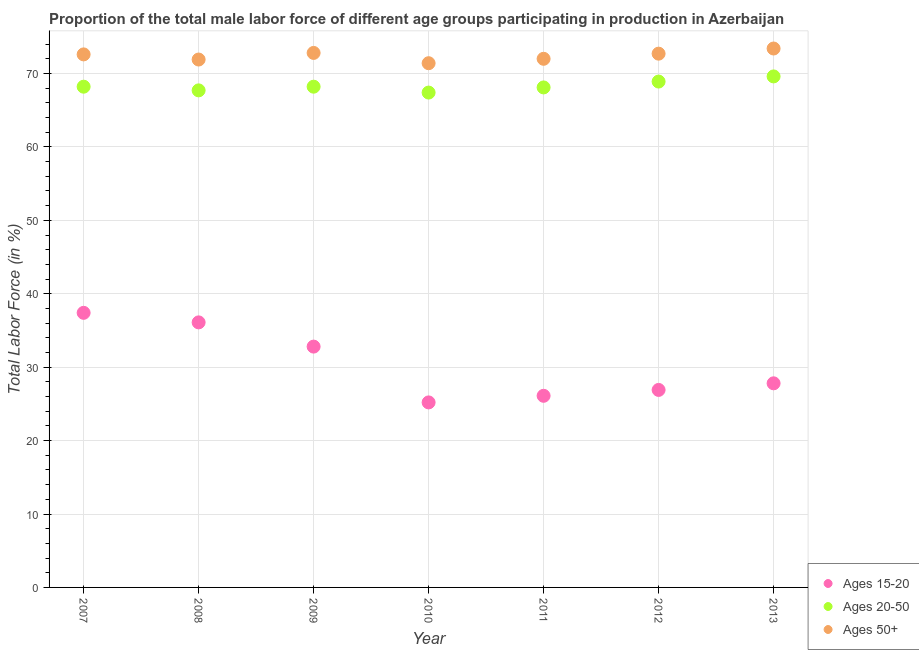How many different coloured dotlines are there?
Keep it short and to the point. 3. What is the percentage of male labor force within the age group 15-20 in 2007?
Keep it short and to the point. 37.4. Across all years, what is the maximum percentage of male labor force within the age group 15-20?
Make the answer very short. 37.4. Across all years, what is the minimum percentage of male labor force above age 50?
Your answer should be compact. 71.4. In which year was the percentage of male labor force above age 50 maximum?
Ensure brevity in your answer.  2013. In which year was the percentage of male labor force above age 50 minimum?
Your answer should be very brief. 2010. What is the total percentage of male labor force above age 50 in the graph?
Make the answer very short. 506.8. What is the difference between the percentage of male labor force within the age group 15-20 in 2009 and that in 2013?
Ensure brevity in your answer.  5. What is the difference between the percentage of male labor force within the age group 20-50 in 2011 and the percentage of male labor force within the age group 15-20 in 2012?
Provide a succinct answer. 41.2. What is the average percentage of male labor force within the age group 20-50 per year?
Give a very brief answer. 68.3. In the year 2008, what is the difference between the percentage of male labor force above age 50 and percentage of male labor force within the age group 20-50?
Offer a very short reply. 4.2. What is the ratio of the percentage of male labor force above age 50 in 2009 to that in 2013?
Offer a terse response. 0.99. Is the percentage of male labor force within the age group 20-50 in 2010 less than that in 2011?
Make the answer very short. Yes. Is the difference between the percentage of male labor force within the age group 20-50 in 2008 and 2012 greater than the difference between the percentage of male labor force above age 50 in 2008 and 2012?
Make the answer very short. No. What is the difference between the highest and the second highest percentage of male labor force within the age group 15-20?
Keep it short and to the point. 1.3. What is the difference between the highest and the lowest percentage of male labor force within the age group 20-50?
Keep it short and to the point. 2.2. Is the sum of the percentage of male labor force within the age group 15-20 in 2009 and 2010 greater than the maximum percentage of male labor force above age 50 across all years?
Offer a terse response. No. Is it the case that in every year, the sum of the percentage of male labor force within the age group 15-20 and percentage of male labor force within the age group 20-50 is greater than the percentage of male labor force above age 50?
Provide a succinct answer. Yes. Does the percentage of male labor force within the age group 15-20 monotonically increase over the years?
Give a very brief answer. No. Is the percentage of male labor force within the age group 15-20 strictly less than the percentage of male labor force above age 50 over the years?
Give a very brief answer. Yes. How many dotlines are there?
Make the answer very short. 3. How many years are there in the graph?
Keep it short and to the point. 7. Where does the legend appear in the graph?
Ensure brevity in your answer.  Bottom right. How are the legend labels stacked?
Ensure brevity in your answer.  Vertical. What is the title of the graph?
Your answer should be compact. Proportion of the total male labor force of different age groups participating in production in Azerbaijan. What is the label or title of the Y-axis?
Provide a succinct answer. Total Labor Force (in %). What is the Total Labor Force (in %) in Ages 15-20 in 2007?
Give a very brief answer. 37.4. What is the Total Labor Force (in %) of Ages 20-50 in 2007?
Offer a terse response. 68.2. What is the Total Labor Force (in %) in Ages 50+ in 2007?
Your answer should be very brief. 72.6. What is the Total Labor Force (in %) in Ages 15-20 in 2008?
Provide a short and direct response. 36.1. What is the Total Labor Force (in %) in Ages 20-50 in 2008?
Offer a terse response. 67.7. What is the Total Labor Force (in %) of Ages 50+ in 2008?
Your answer should be compact. 71.9. What is the Total Labor Force (in %) of Ages 15-20 in 2009?
Your response must be concise. 32.8. What is the Total Labor Force (in %) of Ages 20-50 in 2009?
Offer a terse response. 68.2. What is the Total Labor Force (in %) of Ages 50+ in 2009?
Keep it short and to the point. 72.8. What is the Total Labor Force (in %) in Ages 15-20 in 2010?
Offer a terse response. 25.2. What is the Total Labor Force (in %) in Ages 20-50 in 2010?
Your answer should be compact. 67.4. What is the Total Labor Force (in %) of Ages 50+ in 2010?
Make the answer very short. 71.4. What is the Total Labor Force (in %) in Ages 15-20 in 2011?
Give a very brief answer. 26.1. What is the Total Labor Force (in %) of Ages 20-50 in 2011?
Make the answer very short. 68.1. What is the Total Labor Force (in %) in Ages 50+ in 2011?
Your answer should be compact. 72. What is the Total Labor Force (in %) of Ages 15-20 in 2012?
Provide a succinct answer. 26.9. What is the Total Labor Force (in %) in Ages 20-50 in 2012?
Provide a short and direct response. 68.9. What is the Total Labor Force (in %) of Ages 50+ in 2012?
Offer a terse response. 72.7. What is the Total Labor Force (in %) of Ages 15-20 in 2013?
Ensure brevity in your answer.  27.8. What is the Total Labor Force (in %) of Ages 20-50 in 2013?
Offer a very short reply. 69.6. What is the Total Labor Force (in %) in Ages 50+ in 2013?
Give a very brief answer. 73.4. Across all years, what is the maximum Total Labor Force (in %) in Ages 15-20?
Ensure brevity in your answer.  37.4. Across all years, what is the maximum Total Labor Force (in %) in Ages 20-50?
Offer a terse response. 69.6. Across all years, what is the maximum Total Labor Force (in %) of Ages 50+?
Give a very brief answer. 73.4. Across all years, what is the minimum Total Labor Force (in %) in Ages 15-20?
Your answer should be very brief. 25.2. Across all years, what is the minimum Total Labor Force (in %) in Ages 20-50?
Your answer should be compact. 67.4. Across all years, what is the minimum Total Labor Force (in %) in Ages 50+?
Provide a short and direct response. 71.4. What is the total Total Labor Force (in %) of Ages 15-20 in the graph?
Ensure brevity in your answer.  212.3. What is the total Total Labor Force (in %) in Ages 20-50 in the graph?
Offer a terse response. 478.1. What is the total Total Labor Force (in %) of Ages 50+ in the graph?
Make the answer very short. 506.8. What is the difference between the Total Labor Force (in %) of Ages 50+ in 2007 and that in 2008?
Give a very brief answer. 0.7. What is the difference between the Total Labor Force (in %) in Ages 20-50 in 2007 and that in 2009?
Keep it short and to the point. 0. What is the difference between the Total Labor Force (in %) of Ages 15-20 in 2007 and that in 2010?
Make the answer very short. 12.2. What is the difference between the Total Labor Force (in %) of Ages 50+ in 2007 and that in 2011?
Ensure brevity in your answer.  0.6. What is the difference between the Total Labor Force (in %) of Ages 20-50 in 2007 and that in 2012?
Provide a short and direct response. -0.7. What is the difference between the Total Labor Force (in %) of Ages 50+ in 2007 and that in 2012?
Your answer should be compact. -0.1. What is the difference between the Total Labor Force (in %) in Ages 15-20 in 2008 and that in 2009?
Keep it short and to the point. 3.3. What is the difference between the Total Labor Force (in %) of Ages 20-50 in 2008 and that in 2009?
Your answer should be compact. -0.5. What is the difference between the Total Labor Force (in %) of Ages 15-20 in 2008 and that in 2010?
Keep it short and to the point. 10.9. What is the difference between the Total Labor Force (in %) of Ages 20-50 in 2008 and that in 2010?
Ensure brevity in your answer.  0.3. What is the difference between the Total Labor Force (in %) in Ages 20-50 in 2008 and that in 2011?
Your answer should be very brief. -0.4. What is the difference between the Total Labor Force (in %) of Ages 50+ in 2008 and that in 2011?
Ensure brevity in your answer.  -0.1. What is the difference between the Total Labor Force (in %) of Ages 50+ in 2008 and that in 2012?
Ensure brevity in your answer.  -0.8. What is the difference between the Total Labor Force (in %) in Ages 50+ in 2008 and that in 2013?
Give a very brief answer. -1.5. What is the difference between the Total Labor Force (in %) of Ages 15-20 in 2009 and that in 2010?
Your answer should be very brief. 7.6. What is the difference between the Total Labor Force (in %) of Ages 20-50 in 2009 and that in 2010?
Your response must be concise. 0.8. What is the difference between the Total Labor Force (in %) in Ages 50+ in 2009 and that in 2010?
Keep it short and to the point. 1.4. What is the difference between the Total Labor Force (in %) of Ages 15-20 in 2009 and that in 2011?
Offer a terse response. 6.7. What is the difference between the Total Labor Force (in %) of Ages 20-50 in 2009 and that in 2011?
Offer a very short reply. 0.1. What is the difference between the Total Labor Force (in %) in Ages 50+ in 2009 and that in 2011?
Make the answer very short. 0.8. What is the difference between the Total Labor Force (in %) of Ages 20-50 in 2009 and that in 2012?
Offer a very short reply. -0.7. What is the difference between the Total Labor Force (in %) in Ages 50+ in 2009 and that in 2012?
Ensure brevity in your answer.  0.1. What is the difference between the Total Labor Force (in %) in Ages 15-20 in 2009 and that in 2013?
Give a very brief answer. 5. What is the difference between the Total Labor Force (in %) in Ages 50+ in 2009 and that in 2013?
Offer a very short reply. -0.6. What is the difference between the Total Labor Force (in %) of Ages 15-20 in 2010 and that in 2011?
Offer a very short reply. -0.9. What is the difference between the Total Labor Force (in %) of Ages 20-50 in 2010 and that in 2012?
Keep it short and to the point. -1.5. What is the difference between the Total Labor Force (in %) of Ages 50+ in 2010 and that in 2012?
Ensure brevity in your answer.  -1.3. What is the difference between the Total Labor Force (in %) in Ages 15-20 in 2010 and that in 2013?
Keep it short and to the point. -2.6. What is the difference between the Total Labor Force (in %) of Ages 20-50 in 2011 and that in 2013?
Offer a terse response. -1.5. What is the difference between the Total Labor Force (in %) of Ages 50+ in 2011 and that in 2013?
Your answer should be very brief. -1.4. What is the difference between the Total Labor Force (in %) in Ages 15-20 in 2007 and the Total Labor Force (in %) in Ages 20-50 in 2008?
Offer a very short reply. -30.3. What is the difference between the Total Labor Force (in %) in Ages 15-20 in 2007 and the Total Labor Force (in %) in Ages 50+ in 2008?
Provide a succinct answer. -34.5. What is the difference between the Total Labor Force (in %) in Ages 20-50 in 2007 and the Total Labor Force (in %) in Ages 50+ in 2008?
Your answer should be very brief. -3.7. What is the difference between the Total Labor Force (in %) of Ages 15-20 in 2007 and the Total Labor Force (in %) of Ages 20-50 in 2009?
Offer a terse response. -30.8. What is the difference between the Total Labor Force (in %) of Ages 15-20 in 2007 and the Total Labor Force (in %) of Ages 50+ in 2009?
Provide a short and direct response. -35.4. What is the difference between the Total Labor Force (in %) of Ages 15-20 in 2007 and the Total Labor Force (in %) of Ages 20-50 in 2010?
Your response must be concise. -30. What is the difference between the Total Labor Force (in %) of Ages 15-20 in 2007 and the Total Labor Force (in %) of Ages 50+ in 2010?
Provide a short and direct response. -34. What is the difference between the Total Labor Force (in %) of Ages 15-20 in 2007 and the Total Labor Force (in %) of Ages 20-50 in 2011?
Ensure brevity in your answer.  -30.7. What is the difference between the Total Labor Force (in %) of Ages 15-20 in 2007 and the Total Labor Force (in %) of Ages 50+ in 2011?
Keep it short and to the point. -34.6. What is the difference between the Total Labor Force (in %) of Ages 15-20 in 2007 and the Total Labor Force (in %) of Ages 20-50 in 2012?
Give a very brief answer. -31.5. What is the difference between the Total Labor Force (in %) in Ages 15-20 in 2007 and the Total Labor Force (in %) in Ages 50+ in 2012?
Offer a terse response. -35.3. What is the difference between the Total Labor Force (in %) in Ages 15-20 in 2007 and the Total Labor Force (in %) in Ages 20-50 in 2013?
Provide a short and direct response. -32.2. What is the difference between the Total Labor Force (in %) in Ages 15-20 in 2007 and the Total Labor Force (in %) in Ages 50+ in 2013?
Provide a short and direct response. -36. What is the difference between the Total Labor Force (in %) in Ages 15-20 in 2008 and the Total Labor Force (in %) in Ages 20-50 in 2009?
Keep it short and to the point. -32.1. What is the difference between the Total Labor Force (in %) in Ages 15-20 in 2008 and the Total Labor Force (in %) in Ages 50+ in 2009?
Your answer should be very brief. -36.7. What is the difference between the Total Labor Force (in %) in Ages 20-50 in 2008 and the Total Labor Force (in %) in Ages 50+ in 2009?
Provide a short and direct response. -5.1. What is the difference between the Total Labor Force (in %) of Ages 15-20 in 2008 and the Total Labor Force (in %) of Ages 20-50 in 2010?
Offer a terse response. -31.3. What is the difference between the Total Labor Force (in %) of Ages 15-20 in 2008 and the Total Labor Force (in %) of Ages 50+ in 2010?
Your answer should be very brief. -35.3. What is the difference between the Total Labor Force (in %) of Ages 20-50 in 2008 and the Total Labor Force (in %) of Ages 50+ in 2010?
Provide a succinct answer. -3.7. What is the difference between the Total Labor Force (in %) of Ages 15-20 in 2008 and the Total Labor Force (in %) of Ages 20-50 in 2011?
Give a very brief answer. -32. What is the difference between the Total Labor Force (in %) in Ages 15-20 in 2008 and the Total Labor Force (in %) in Ages 50+ in 2011?
Your answer should be compact. -35.9. What is the difference between the Total Labor Force (in %) of Ages 15-20 in 2008 and the Total Labor Force (in %) of Ages 20-50 in 2012?
Your answer should be very brief. -32.8. What is the difference between the Total Labor Force (in %) of Ages 15-20 in 2008 and the Total Labor Force (in %) of Ages 50+ in 2012?
Your answer should be compact. -36.6. What is the difference between the Total Labor Force (in %) in Ages 20-50 in 2008 and the Total Labor Force (in %) in Ages 50+ in 2012?
Offer a terse response. -5. What is the difference between the Total Labor Force (in %) in Ages 15-20 in 2008 and the Total Labor Force (in %) in Ages 20-50 in 2013?
Your answer should be very brief. -33.5. What is the difference between the Total Labor Force (in %) in Ages 15-20 in 2008 and the Total Labor Force (in %) in Ages 50+ in 2013?
Give a very brief answer. -37.3. What is the difference between the Total Labor Force (in %) in Ages 15-20 in 2009 and the Total Labor Force (in %) in Ages 20-50 in 2010?
Offer a very short reply. -34.6. What is the difference between the Total Labor Force (in %) of Ages 15-20 in 2009 and the Total Labor Force (in %) of Ages 50+ in 2010?
Provide a short and direct response. -38.6. What is the difference between the Total Labor Force (in %) in Ages 20-50 in 2009 and the Total Labor Force (in %) in Ages 50+ in 2010?
Keep it short and to the point. -3.2. What is the difference between the Total Labor Force (in %) in Ages 15-20 in 2009 and the Total Labor Force (in %) in Ages 20-50 in 2011?
Keep it short and to the point. -35.3. What is the difference between the Total Labor Force (in %) in Ages 15-20 in 2009 and the Total Labor Force (in %) in Ages 50+ in 2011?
Your response must be concise. -39.2. What is the difference between the Total Labor Force (in %) in Ages 20-50 in 2009 and the Total Labor Force (in %) in Ages 50+ in 2011?
Give a very brief answer. -3.8. What is the difference between the Total Labor Force (in %) of Ages 15-20 in 2009 and the Total Labor Force (in %) of Ages 20-50 in 2012?
Keep it short and to the point. -36.1. What is the difference between the Total Labor Force (in %) in Ages 15-20 in 2009 and the Total Labor Force (in %) in Ages 50+ in 2012?
Make the answer very short. -39.9. What is the difference between the Total Labor Force (in %) of Ages 20-50 in 2009 and the Total Labor Force (in %) of Ages 50+ in 2012?
Make the answer very short. -4.5. What is the difference between the Total Labor Force (in %) in Ages 15-20 in 2009 and the Total Labor Force (in %) in Ages 20-50 in 2013?
Give a very brief answer. -36.8. What is the difference between the Total Labor Force (in %) in Ages 15-20 in 2009 and the Total Labor Force (in %) in Ages 50+ in 2013?
Keep it short and to the point. -40.6. What is the difference between the Total Labor Force (in %) in Ages 20-50 in 2009 and the Total Labor Force (in %) in Ages 50+ in 2013?
Your answer should be very brief. -5.2. What is the difference between the Total Labor Force (in %) of Ages 15-20 in 2010 and the Total Labor Force (in %) of Ages 20-50 in 2011?
Offer a very short reply. -42.9. What is the difference between the Total Labor Force (in %) of Ages 15-20 in 2010 and the Total Labor Force (in %) of Ages 50+ in 2011?
Your response must be concise. -46.8. What is the difference between the Total Labor Force (in %) in Ages 15-20 in 2010 and the Total Labor Force (in %) in Ages 20-50 in 2012?
Offer a terse response. -43.7. What is the difference between the Total Labor Force (in %) of Ages 15-20 in 2010 and the Total Labor Force (in %) of Ages 50+ in 2012?
Offer a very short reply. -47.5. What is the difference between the Total Labor Force (in %) of Ages 20-50 in 2010 and the Total Labor Force (in %) of Ages 50+ in 2012?
Your answer should be very brief. -5.3. What is the difference between the Total Labor Force (in %) of Ages 15-20 in 2010 and the Total Labor Force (in %) of Ages 20-50 in 2013?
Offer a terse response. -44.4. What is the difference between the Total Labor Force (in %) in Ages 15-20 in 2010 and the Total Labor Force (in %) in Ages 50+ in 2013?
Give a very brief answer. -48.2. What is the difference between the Total Labor Force (in %) in Ages 20-50 in 2010 and the Total Labor Force (in %) in Ages 50+ in 2013?
Keep it short and to the point. -6. What is the difference between the Total Labor Force (in %) in Ages 15-20 in 2011 and the Total Labor Force (in %) in Ages 20-50 in 2012?
Ensure brevity in your answer.  -42.8. What is the difference between the Total Labor Force (in %) of Ages 15-20 in 2011 and the Total Labor Force (in %) of Ages 50+ in 2012?
Provide a short and direct response. -46.6. What is the difference between the Total Labor Force (in %) in Ages 20-50 in 2011 and the Total Labor Force (in %) in Ages 50+ in 2012?
Provide a succinct answer. -4.6. What is the difference between the Total Labor Force (in %) of Ages 15-20 in 2011 and the Total Labor Force (in %) of Ages 20-50 in 2013?
Offer a very short reply. -43.5. What is the difference between the Total Labor Force (in %) in Ages 15-20 in 2011 and the Total Labor Force (in %) in Ages 50+ in 2013?
Give a very brief answer. -47.3. What is the difference between the Total Labor Force (in %) in Ages 15-20 in 2012 and the Total Labor Force (in %) in Ages 20-50 in 2013?
Your answer should be compact. -42.7. What is the difference between the Total Labor Force (in %) of Ages 15-20 in 2012 and the Total Labor Force (in %) of Ages 50+ in 2013?
Give a very brief answer. -46.5. What is the average Total Labor Force (in %) in Ages 15-20 per year?
Keep it short and to the point. 30.33. What is the average Total Labor Force (in %) in Ages 20-50 per year?
Offer a terse response. 68.3. What is the average Total Labor Force (in %) in Ages 50+ per year?
Keep it short and to the point. 72.4. In the year 2007, what is the difference between the Total Labor Force (in %) of Ages 15-20 and Total Labor Force (in %) of Ages 20-50?
Keep it short and to the point. -30.8. In the year 2007, what is the difference between the Total Labor Force (in %) in Ages 15-20 and Total Labor Force (in %) in Ages 50+?
Your answer should be very brief. -35.2. In the year 2007, what is the difference between the Total Labor Force (in %) of Ages 20-50 and Total Labor Force (in %) of Ages 50+?
Your answer should be very brief. -4.4. In the year 2008, what is the difference between the Total Labor Force (in %) of Ages 15-20 and Total Labor Force (in %) of Ages 20-50?
Ensure brevity in your answer.  -31.6. In the year 2008, what is the difference between the Total Labor Force (in %) of Ages 15-20 and Total Labor Force (in %) of Ages 50+?
Offer a terse response. -35.8. In the year 2009, what is the difference between the Total Labor Force (in %) in Ages 15-20 and Total Labor Force (in %) in Ages 20-50?
Provide a short and direct response. -35.4. In the year 2009, what is the difference between the Total Labor Force (in %) in Ages 15-20 and Total Labor Force (in %) in Ages 50+?
Make the answer very short. -40. In the year 2009, what is the difference between the Total Labor Force (in %) in Ages 20-50 and Total Labor Force (in %) in Ages 50+?
Ensure brevity in your answer.  -4.6. In the year 2010, what is the difference between the Total Labor Force (in %) in Ages 15-20 and Total Labor Force (in %) in Ages 20-50?
Keep it short and to the point. -42.2. In the year 2010, what is the difference between the Total Labor Force (in %) in Ages 15-20 and Total Labor Force (in %) in Ages 50+?
Your response must be concise. -46.2. In the year 2011, what is the difference between the Total Labor Force (in %) in Ages 15-20 and Total Labor Force (in %) in Ages 20-50?
Your answer should be very brief. -42. In the year 2011, what is the difference between the Total Labor Force (in %) of Ages 15-20 and Total Labor Force (in %) of Ages 50+?
Provide a short and direct response. -45.9. In the year 2011, what is the difference between the Total Labor Force (in %) in Ages 20-50 and Total Labor Force (in %) in Ages 50+?
Offer a very short reply. -3.9. In the year 2012, what is the difference between the Total Labor Force (in %) of Ages 15-20 and Total Labor Force (in %) of Ages 20-50?
Your answer should be compact. -42. In the year 2012, what is the difference between the Total Labor Force (in %) of Ages 15-20 and Total Labor Force (in %) of Ages 50+?
Provide a short and direct response. -45.8. In the year 2013, what is the difference between the Total Labor Force (in %) of Ages 15-20 and Total Labor Force (in %) of Ages 20-50?
Give a very brief answer. -41.8. In the year 2013, what is the difference between the Total Labor Force (in %) of Ages 15-20 and Total Labor Force (in %) of Ages 50+?
Make the answer very short. -45.6. What is the ratio of the Total Labor Force (in %) in Ages 15-20 in 2007 to that in 2008?
Your answer should be compact. 1.04. What is the ratio of the Total Labor Force (in %) in Ages 20-50 in 2007 to that in 2008?
Offer a very short reply. 1.01. What is the ratio of the Total Labor Force (in %) in Ages 50+ in 2007 to that in 2008?
Make the answer very short. 1.01. What is the ratio of the Total Labor Force (in %) in Ages 15-20 in 2007 to that in 2009?
Make the answer very short. 1.14. What is the ratio of the Total Labor Force (in %) in Ages 20-50 in 2007 to that in 2009?
Offer a terse response. 1. What is the ratio of the Total Labor Force (in %) of Ages 15-20 in 2007 to that in 2010?
Provide a succinct answer. 1.48. What is the ratio of the Total Labor Force (in %) of Ages 20-50 in 2007 to that in 2010?
Offer a terse response. 1.01. What is the ratio of the Total Labor Force (in %) in Ages 50+ in 2007 to that in 2010?
Your answer should be compact. 1.02. What is the ratio of the Total Labor Force (in %) of Ages 15-20 in 2007 to that in 2011?
Your answer should be compact. 1.43. What is the ratio of the Total Labor Force (in %) in Ages 50+ in 2007 to that in 2011?
Your response must be concise. 1.01. What is the ratio of the Total Labor Force (in %) in Ages 15-20 in 2007 to that in 2012?
Ensure brevity in your answer.  1.39. What is the ratio of the Total Labor Force (in %) of Ages 20-50 in 2007 to that in 2012?
Provide a short and direct response. 0.99. What is the ratio of the Total Labor Force (in %) of Ages 50+ in 2007 to that in 2012?
Offer a terse response. 1. What is the ratio of the Total Labor Force (in %) in Ages 15-20 in 2007 to that in 2013?
Give a very brief answer. 1.35. What is the ratio of the Total Labor Force (in %) in Ages 20-50 in 2007 to that in 2013?
Offer a very short reply. 0.98. What is the ratio of the Total Labor Force (in %) of Ages 15-20 in 2008 to that in 2009?
Provide a short and direct response. 1.1. What is the ratio of the Total Labor Force (in %) in Ages 20-50 in 2008 to that in 2009?
Give a very brief answer. 0.99. What is the ratio of the Total Labor Force (in %) of Ages 50+ in 2008 to that in 2009?
Your response must be concise. 0.99. What is the ratio of the Total Labor Force (in %) of Ages 15-20 in 2008 to that in 2010?
Offer a very short reply. 1.43. What is the ratio of the Total Labor Force (in %) in Ages 50+ in 2008 to that in 2010?
Ensure brevity in your answer.  1.01. What is the ratio of the Total Labor Force (in %) of Ages 15-20 in 2008 to that in 2011?
Your answer should be compact. 1.38. What is the ratio of the Total Labor Force (in %) in Ages 15-20 in 2008 to that in 2012?
Keep it short and to the point. 1.34. What is the ratio of the Total Labor Force (in %) in Ages 20-50 in 2008 to that in 2012?
Ensure brevity in your answer.  0.98. What is the ratio of the Total Labor Force (in %) of Ages 50+ in 2008 to that in 2012?
Keep it short and to the point. 0.99. What is the ratio of the Total Labor Force (in %) in Ages 15-20 in 2008 to that in 2013?
Your response must be concise. 1.3. What is the ratio of the Total Labor Force (in %) in Ages 20-50 in 2008 to that in 2013?
Your answer should be very brief. 0.97. What is the ratio of the Total Labor Force (in %) in Ages 50+ in 2008 to that in 2013?
Provide a short and direct response. 0.98. What is the ratio of the Total Labor Force (in %) of Ages 15-20 in 2009 to that in 2010?
Make the answer very short. 1.3. What is the ratio of the Total Labor Force (in %) in Ages 20-50 in 2009 to that in 2010?
Keep it short and to the point. 1.01. What is the ratio of the Total Labor Force (in %) in Ages 50+ in 2009 to that in 2010?
Keep it short and to the point. 1.02. What is the ratio of the Total Labor Force (in %) in Ages 15-20 in 2009 to that in 2011?
Provide a short and direct response. 1.26. What is the ratio of the Total Labor Force (in %) in Ages 50+ in 2009 to that in 2011?
Provide a short and direct response. 1.01. What is the ratio of the Total Labor Force (in %) of Ages 15-20 in 2009 to that in 2012?
Offer a very short reply. 1.22. What is the ratio of the Total Labor Force (in %) in Ages 20-50 in 2009 to that in 2012?
Offer a very short reply. 0.99. What is the ratio of the Total Labor Force (in %) in Ages 15-20 in 2009 to that in 2013?
Offer a very short reply. 1.18. What is the ratio of the Total Labor Force (in %) in Ages 20-50 in 2009 to that in 2013?
Your answer should be compact. 0.98. What is the ratio of the Total Labor Force (in %) of Ages 15-20 in 2010 to that in 2011?
Your answer should be very brief. 0.97. What is the ratio of the Total Labor Force (in %) of Ages 15-20 in 2010 to that in 2012?
Offer a very short reply. 0.94. What is the ratio of the Total Labor Force (in %) in Ages 20-50 in 2010 to that in 2012?
Your answer should be compact. 0.98. What is the ratio of the Total Labor Force (in %) of Ages 50+ in 2010 to that in 2012?
Keep it short and to the point. 0.98. What is the ratio of the Total Labor Force (in %) in Ages 15-20 in 2010 to that in 2013?
Provide a short and direct response. 0.91. What is the ratio of the Total Labor Force (in %) of Ages 20-50 in 2010 to that in 2013?
Offer a terse response. 0.97. What is the ratio of the Total Labor Force (in %) in Ages 50+ in 2010 to that in 2013?
Offer a very short reply. 0.97. What is the ratio of the Total Labor Force (in %) of Ages 15-20 in 2011 to that in 2012?
Keep it short and to the point. 0.97. What is the ratio of the Total Labor Force (in %) of Ages 20-50 in 2011 to that in 2012?
Provide a succinct answer. 0.99. What is the ratio of the Total Labor Force (in %) of Ages 15-20 in 2011 to that in 2013?
Your response must be concise. 0.94. What is the ratio of the Total Labor Force (in %) in Ages 20-50 in 2011 to that in 2013?
Make the answer very short. 0.98. What is the ratio of the Total Labor Force (in %) of Ages 50+ in 2011 to that in 2013?
Offer a terse response. 0.98. What is the ratio of the Total Labor Force (in %) in Ages 15-20 in 2012 to that in 2013?
Provide a short and direct response. 0.97. What is the ratio of the Total Labor Force (in %) of Ages 20-50 in 2012 to that in 2013?
Make the answer very short. 0.99. What is the ratio of the Total Labor Force (in %) of Ages 50+ in 2012 to that in 2013?
Your response must be concise. 0.99. What is the difference between the highest and the second highest Total Labor Force (in %) of Ages 15-20?
Ensure brevity in your answer.  1.3. What is the difference between the highest and the second highest Total Labor Force (in %) of Ages 20-50?
Your answer should be compact. 0.7. What is the difference between the highest and the second highest Total Labor Force (in %) in Ages 50+?
Offer a terse response. 0.6. What is the difference between the highest and the lowest Total Labor Force (in %) of Ages 20-50?
Offer a terse response. 2.2. 